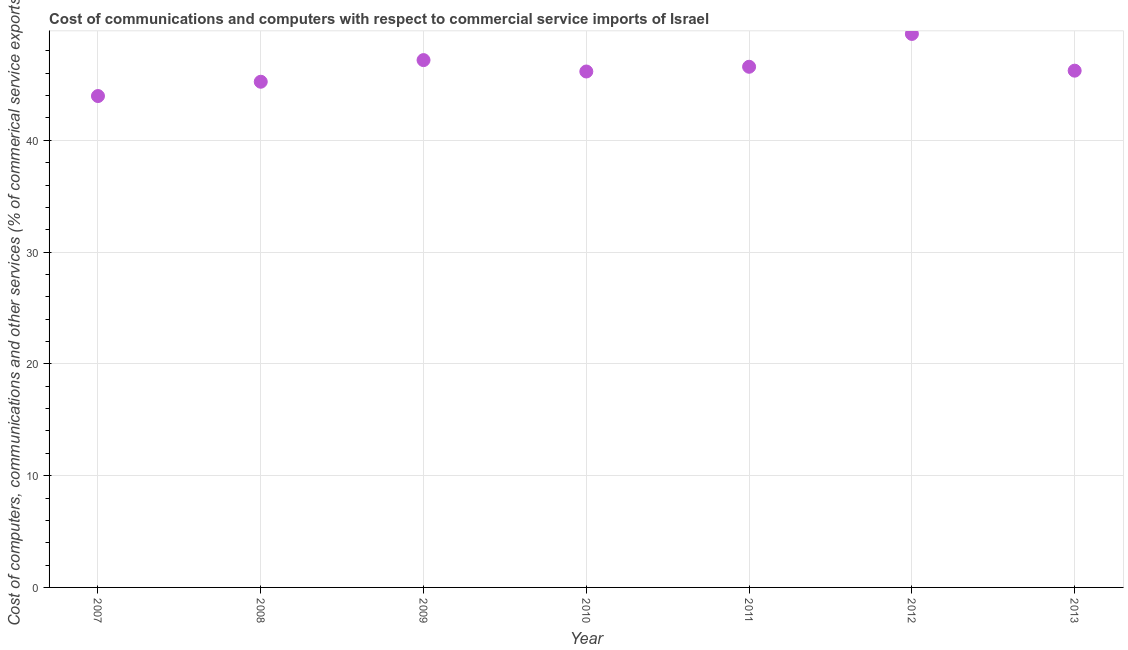What is the cost of communications in 2010?
Your answer should be compact. 46.16. Across all years, what is the maximum  computer and other services?
Provide a short and direct response. 49.52. Across all years, what is the minimum cost of communications?
Ensure brevity in your answer.  43.96. In which year was the  computer and other services maximum?
Keep it short and to the point. 2012. In which year was the cost of communications minimum?
Offer a terse response. 2007. What is the sum of the  computer and other services?
Provide a succinct answer. 324.86. What is the difference between the  computer and other services in 2007 and 2012?
Offer a terse response. -5.56. What is the average cost of communications per year?
Provide a succinct answer. 46.41. What is the median  computer and other services?
Offer a very short reply. 46.23. In how many years, is the  computer and other services greater than 26 %?
Offer a very short reply. 7. Do a majority of the years between 2007 and 2011 (inclusive) have  computer and other services greater than 26 %?
Keep it short and to the point. Yes. What is the ratio of the  computer and other services in 2010 to that in 2013?
Your response must be concise. 1. What is the difference between the highest and the second highest cost of communications?
Provide a short and direct response. 2.34. What is the difference between the highest and the lowest cost of communications?
Your answer should be very brief. 5.56. Does the  computer and other services monotonically increase over the years?
Your response must be concise. No. What is the difference between two consecutive major ticks on the Y-axis?
Provide a short and direct response. 10. Does the graph contain grids?
Make the answer very short. Yes. What is the title of the graph?
Your answer should be compact. Cost of communications and computers with respect to commercial service imports of Israel. What is the label or title of the Y-axis?
Your answer should be compact. Cost of computers, communications and other services (% of commerical service exports). What is the Cost of computers, communications and other services (% of commerical service exports) in 2007?
Make the answer very short. 43.96. What is the Cost of computers, communications and other services (% of commerical service exports) in 2008?
Keep it short and to the point. 45.24. What is the Cost of computers, communications and other services (% of commerical service exports) in 2009?
Your response must be concise. 47.18. What is the Cost of computers, communications and other services (% of commerical service exports) in 2010?
Your answer should be very brief. 46.16. What is the Cost of computers, communications and other services (% of commerical service exports) in 2011?
Your answer should be very brief. 46.58. What is the Cost of computers, communications and other services (% of commerical service exports) in 2012?
Keep it short and to the point. 49.52. What is the Cost of computers, communications and other services (% of commerical service exports) in 2013?
Offer a terse response. 46.23. What is the difference between the Cost of computers, communications and other services (% of commerical service exports) in 2007 and 2008?
Offer a very short reply. -1.28. What is the difference between the Cost of computers, communications and other services (% of commerical service exports) in 2007 and 2009?
Your answer should be very brief. -3.21. What is the difference between the Cost of computers, communications and other services (% of commerical service exports) in 2007 and 2010?
Ensure brevity in your answer.  -2.2. What is the difference between the Cost of computers, communications and other services (% of commerical service exports) in 2007 and 2011?
Make the answer very short. -2.62. What is the difference between the Cost of computers, communications and other services (% of commerical service exports) in 2007 and 2012?
Your answer should be very brief. -5.56. What is the difference between the Cost of computers, communications and other services (% of commerical service exports) in 2007 and 2013?
Your answer should be compact. -2.27. What is the difference between the Cost of computers, communications and other services (% of commerical service exports) in 2008 and 2009?
Your response must be concise. -1.94. What is the difference between the Cost of computers, communications and other services (% of commerical service exports) in 2008 and 2010?
Offer a terse response. -0.92. What is the difference between the Cost of computers, communications and other services (% of commerical service exports) in 2008 and 2011?
Your answer should be compact. -1.34. What is the difference between the Cost of computers, communications and other services (% of commerical service exports) in 2008 and 2012?
Offer a terse response. -4.28. What is the difference between the Cost of computers, communications and other services (% of commerical service exports) in 2008 and 2013?
Your answer should be very brief. -0.99. What is the difference between the Cost of computers, communications and other services (% of commerical service exports) in 2009 and 2010?
Your response must be concise. 1.02. What is the difference between the Cost of computers, communications and other services (% of commerical service exports) in 2009 and 2011?
Keep it short and to the point. 0.6. What is the difference between the Cost of computers, communications and other services (% of commerical service exports) in 2009 and 2012?
Ensure brevity in your answer.  -2.34. What is the difference between the Cost of computers, communications and other services (% of commerical service exports) in 2009 and 2013?
Make the answer very short. 0.95. What is the difference between the Cost of computers, communications and other services (% of commerical service exports) in 2010 and 2011?
Your answer should be very brief. -0.42. What is the difference between the Cost of computers, communications and other services (% of commerical service exports) in 2010 and 2012?
Give a very brief answer. -3.36. What is the difference between the Cost of computers, communications and other services (% of commerical service exports) in 2010 and 2013?
Give a very brief answer. -0.07. What is the difference between the Cost of computers, communications and other services (% of commerical service exports) in 2011 and 2012?
Offer a very short reply. -2.94. What is the difference between the Cost of computers, communications and other services (% of commerical service exports) in 2011 and 2013?
Keep it short and to the point. 0.35. What is the difference between the Cost of computers, communications and other services (% of commerical service exports) in 2012 and 2013?
Your answer should be compact. 3.29. What is the ratio of the Cost of computers, communications and other services (% of commerical service exports) in 2007 to that in 2009?
Provide a short and direct response. 0.93. What is the ratio of the Cost of computers, communications and other services (% of commerical service exports) in 2007 to that in 2010?
Offer a very short reply. 0.95. What is the ratio of the Cost of computers, communications and other services (% of commerical service exports) in 2007 to that in 2011?
Your response must be concise. 0.94. What is the ratio of the Cost of computers, communications and other services (% of commerical service exports) in 2007 to that in 2012?
Your answer should be compact. 0.89. What is the ratio of the Cost of computers, communications and other services (% of commerical service exports) in 2007 to that in 2013?
Your answer should be very brief. 0.95. What is the ratio of the Cost of computers, communications and other services (% of commerical service exports) in 2008 to that in 2010?
Your answer should be very brief. 0.98. What is the ratio of the Cost of computers, communications and other services (% of commerical service exports) in 2008 to that in 2011?
Your response must be concise. 0.97. What is the ratio of the Cost of computers, communications and other services (% of commerical service exports) in 2008 to that in 2012?
Make the answer very short. 0.91. What is the ratio of the Cost of computers, communications and other services (% of commerical service exports) in 2009 to that in 2010?
Offer a very short reply. 1.02. What is the ratio of the Cost of computers, communications and other services (% of commerical service exports) in 2009 to that in 2011?
Offer a very short reply. 1.01. What is the ratio of the Cost of computers, communications and other services (% of commerical service exports) in 2009 to that in 2012?
Offer a terse response. 0.95. What is the ratio of the Cost of computers, communications and other services (% of commerical service exports) in 2010 to that in 2011?
Give a very brief answer. 0.99. What is the ratio of the Cost of computers, communications and other services (% of commerical service exports) in 2010 to that in 2012?
Provide a succinct answer. 0.93. What is the ratio of the Cost of computers, communications and other services (% of commerical service exports) in 2011 to that in 2012?
Your answer should be compact. 0.94. What is the ratio of the Cost of computers, communications and other services (% of commerical service exports) in 2012 to that in 2013?
Your answer should be compact. 1.07. 